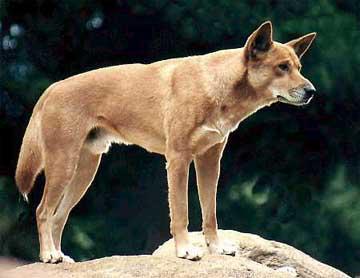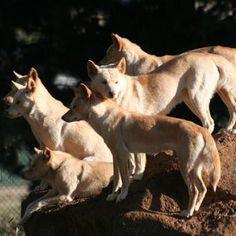The first image is the image on the left, the second image is the image on the right. For the images displayed, is the sentence "There ais at least one dog standing on a rocky hill" factually correct? Answer yes or no. Yes. The first image is the image on the left, the second image is the image on the right. Given the left and right images, does the statement "There appear to be exactly eight dogs." hold true? Answer yes or no. No. 